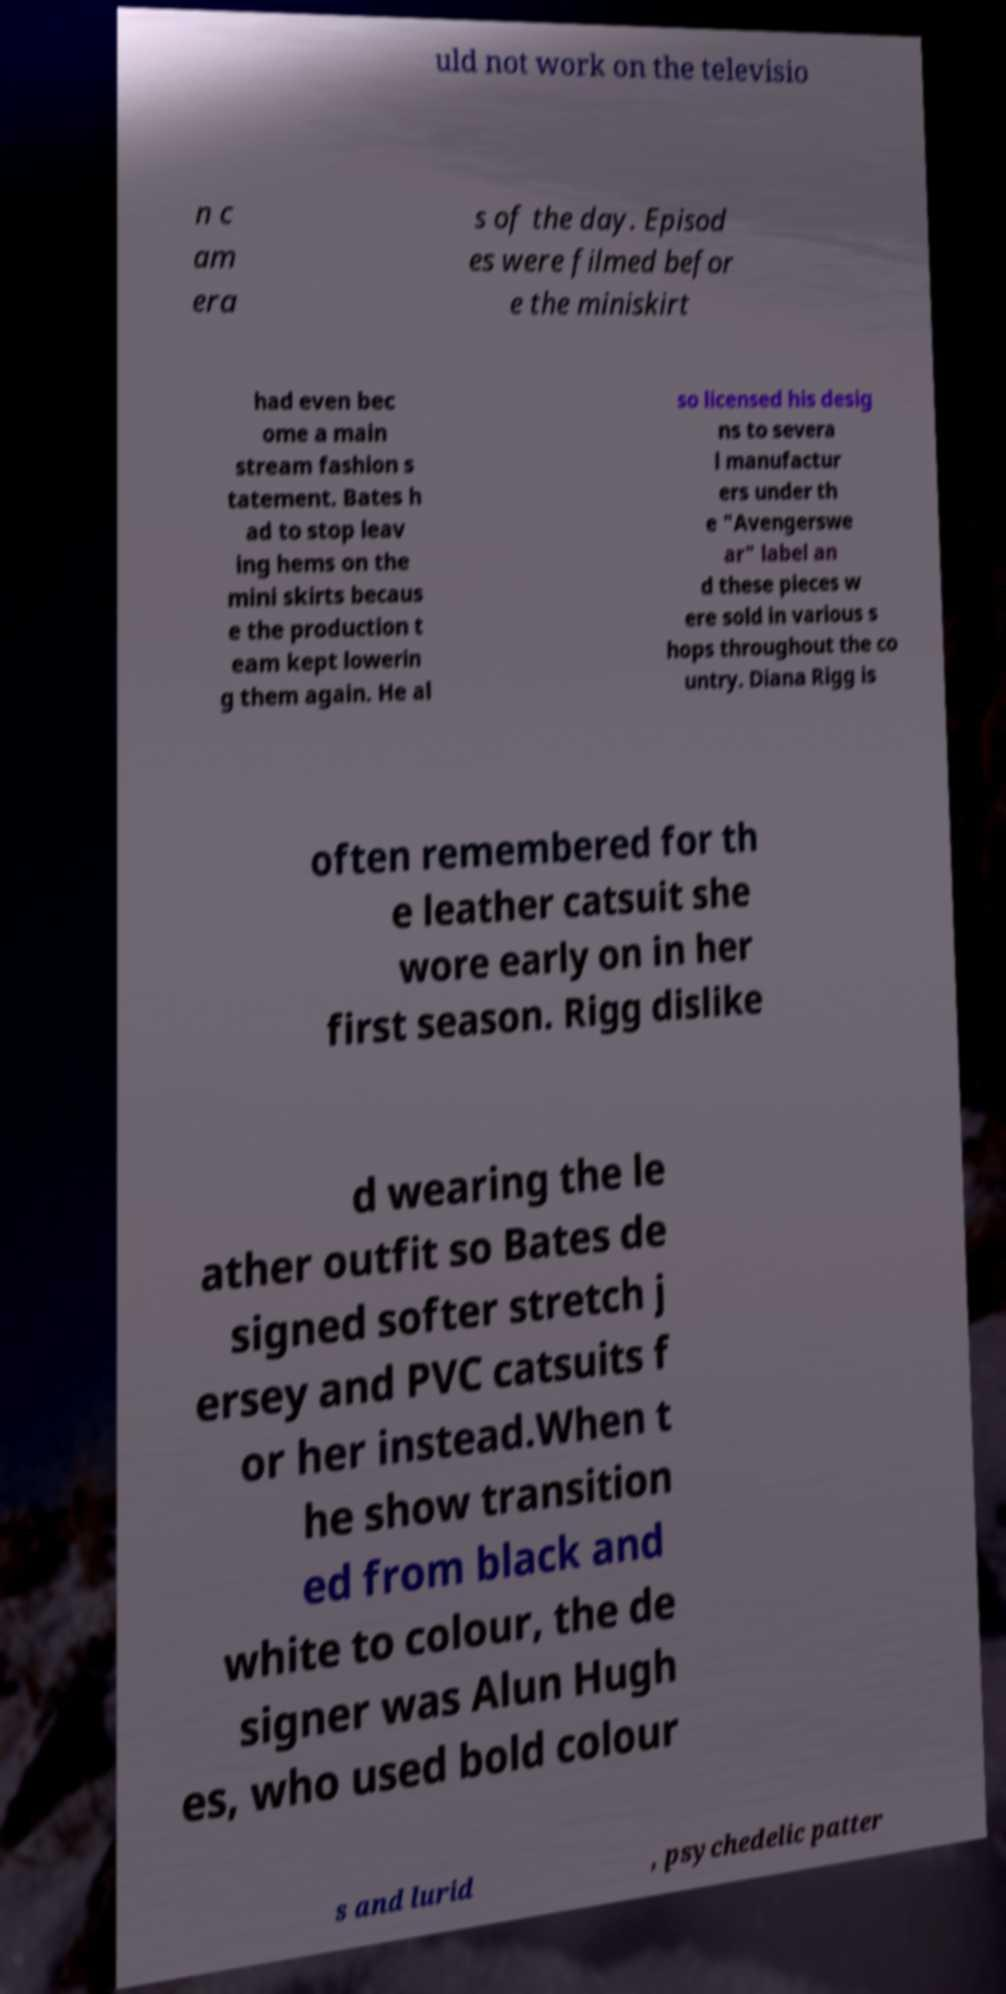Could you extract and type out the text from this image? uld not work on the televisio n c am era s of the day. Episod es were filmed befor e the miniskirt had even bec ome a main stream fashion s tatement. Bates h ad to stop leav ing hems on the mini skirts becaus e the production t eam kept lowerin g them again. He al so licensed his desig ns to severa l manufactur ers under th e "Avengerswe ar" label an d these pieces w ere sold in various s hops throughout the co untry. Diana Rigg is often remembered for th e leather catsuit she wore early on in her first season. Rigg dislike d wearing the le ather outfit so Bates de signed softer stretch j ersey and PVC catsuits f or her instead.When t he show transition ed from black and white to colour, the de signer was Alun Hugh es, who used bold colour s and lurid , psychedelic patter 